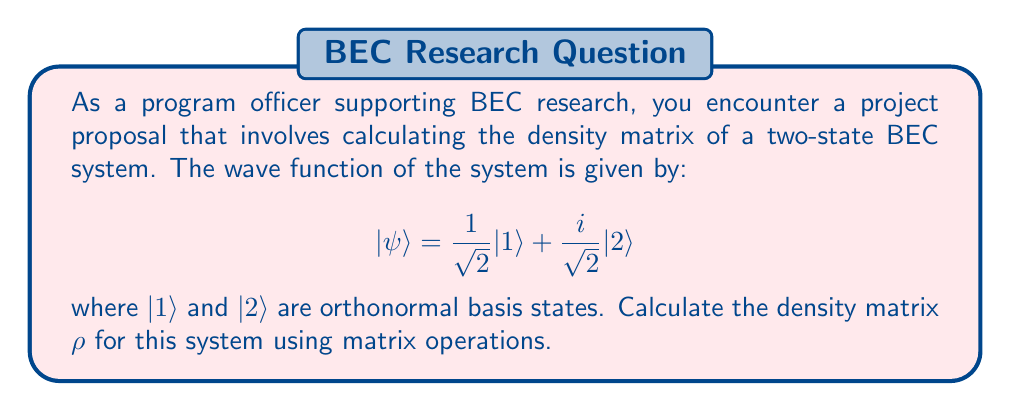What is the answer to this math problem? To calculate the density matrix $\rho$ for the given BEC system, we'll follow these steps:

1) The density matrix is defined as $\rho = |\psi\rangle\langle\psi|$, where $|\psi\rangle$ is the state vector and $\langle\psi|$ is its conjugate transpose.

2) First, let's express $|\psi\rangle$ as a column vector:

   $$ |\psi\rangle = \begin{pmatrix} \frac{1}{\sqrt{2}} \\ \frac{i}{\sqrt{2}} \end{pmatrix} $$

3) Now, we need to calculate $\langle\psi|$, which is the conjugate transpose of $|\psi\rangle$:

   $$ \langle\psi| = \begin{pmatrix} \frac{1}{\sqrt{2}} & -\frac{i}{\sqrt{2}} \end{pmatrix} $$

4) To obtain $\rho$, we multiply $|\psi\rangle$ by $\langle\psi|$:

   $$ \rho = |\psi\rangle\langle\psi| = \begin{pmatrix} \frac{1}{\sqrt{2}} \\ \frac{i}{\sqrt{2}} \end{pmatrix} \begin{pmatrix} \frac{1}{\sqrt{2}} & -\frac{i}{\sqrt{2}} \end{pmatrix} $$

5) Performing the matrix multiplication:

   $$ \rho = \begin{pmatrix} 
   (\frac{1}{\sqrt{2}})(\frac{1}{\sqrt{2}}) & (\frac{1}{\sqrt{2}})(-\frac{i}{\sqrt{2}}) \\
   (\frac{i}{\sqrt{2}})(\frac{1}{\sqrt{2}}) & (\frac{i}{\sqrt{2}})(-\frac{i}{\sqrt{2}})
   \end{pmatrix} $$

6) Simplifying:

   $$ \rho = \begin{pmatrix} 
   \frac{1}{2} & -\frac{i}{2} \\
   \frac{i}{2} & \frac{1}{2}
   \end{pmatrix} $$

This is the density matrix for the given two-state BEC system.
Answer: $$ \rho = \begin{pmatrix} 
\frac{1}{2} & -\frac{i}{2} \\
\frac{i}{2} & \frac{1}{2}
\end{pmatrix} $$ 